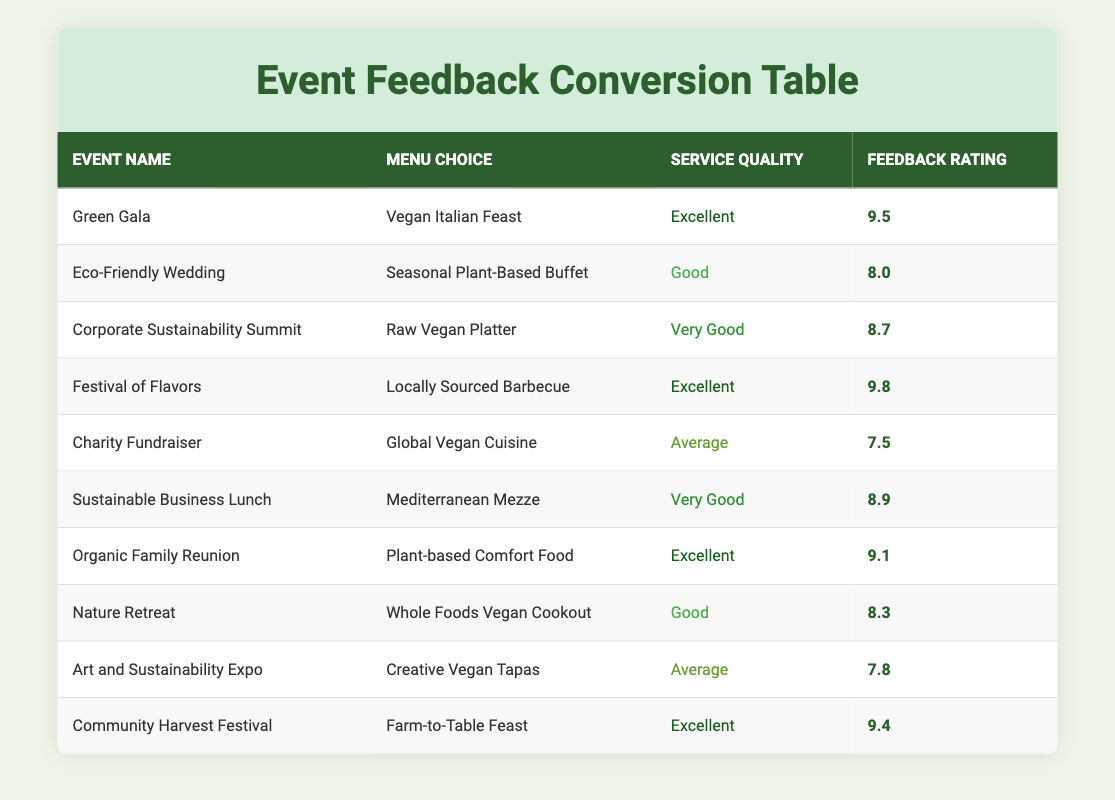What was the feedback rating for the "Eco-Friendly Wedding"? The feedback rating for the "Eco-Friendly Wedding" can be found in the row corresponding to that event, which shows a rating of 8.0.
Answer: 8.0 Which event had the highest feedback rating? To find the highest feedback rating, we compare the ratings for each event listed in the table. The highest rating is 9.8, which corresponds to the "Festival of Flavors".
Answer: Festival of Flavors Is the service quality for "Charity Fundraiser" rated as average? Looking at the service quality column for the "Charity Fundraiser" event, it is classified as "Average". Therefore, the statement is true.
Answer: Yes What is the average feedback rating for events with excellent service quality? We identify the events with "Excellent" service quality: "Green Gala" (9.5), "Festival of Flavors" (9.8), "Organic Family Reunion" (9.1), and "Community Harvest Festival" (9.4). To find the average, we sum these ratings: (9.5 + 9.8 + 9.1 + 9.4) = 37.8. There are 4 such events, so the average is 37.8/4 = 9.45.
Answer: 9.45 How many events had a feedback rating of 8.5 or above? We check each event's feedback rating in the table. The events with ratings 8.5 or above are: "Green Gala" (9.5), "Festival of Flavors" (9.8), "Corporate Sustainability Summit" (8.7), "Sustainable Business Lunch" (8.9), "Organic Family Reunion" (9.1), "Community Harvest Festival" (9.4). That sums up to 6 events with ratings that meet the criteria.
Answer: 6 